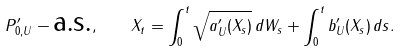<formula> <loc_0><loc_0><loc_500><loc_500>P ^ { \prime } _ { 0 , U } - \text {a.s.} , \quad X _ { t } = \int _ { 0 } ^ { t } \sqrt { a ^ { \prime } _ { U } ( X _ { s } ) } \, d W _ { s } + \int _ { 0 } ^ { t } b ^ { \prime } _ { U } ( X _ { s } ) \, d s .</formula> 